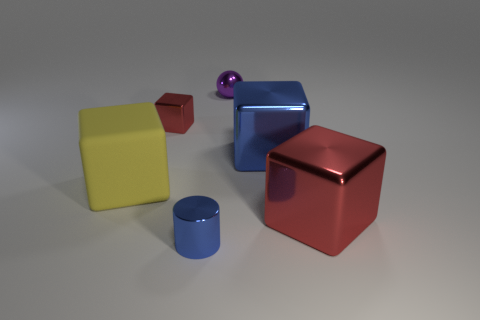What size is the object that is the same color as the cylinder?
Your answer should be very brief. Large. There is a metallic object that is the same color as the small metallic cube; what shape is it?
Give a very brief answer. Cube. The red block that is right of the tiny object on the left side of the cylinder is made of what material?
Your answer should be very brief. Metal. Are there any tiny brown blocks made of the same material as the blue block?
Ensure brevity in your answer.  No. Are there any purple objects on the left side of the small metal thing on the left side of the blue cylinder?
Provide a short and direct response. No. There is a blue object that is to the right of the purple sphere; what is it made of?
Give a very brief answer. Metal. Is the big yellow matte thing the same shape as the purple metallic object?
Give a very brief answer. No. What is the color of the object on the left side of the red cube that is behind the blue thing right of the tiny blue cylinder?
Provide a succinct answer. Yellow. What number of other tiny things have the same shape as the purple metallic object?
Your response must be concise. 0. How big is the blue metallic thing that is behind the big red object that is right of the tiny blue shiny thing?
Offer a terse response. Large. 